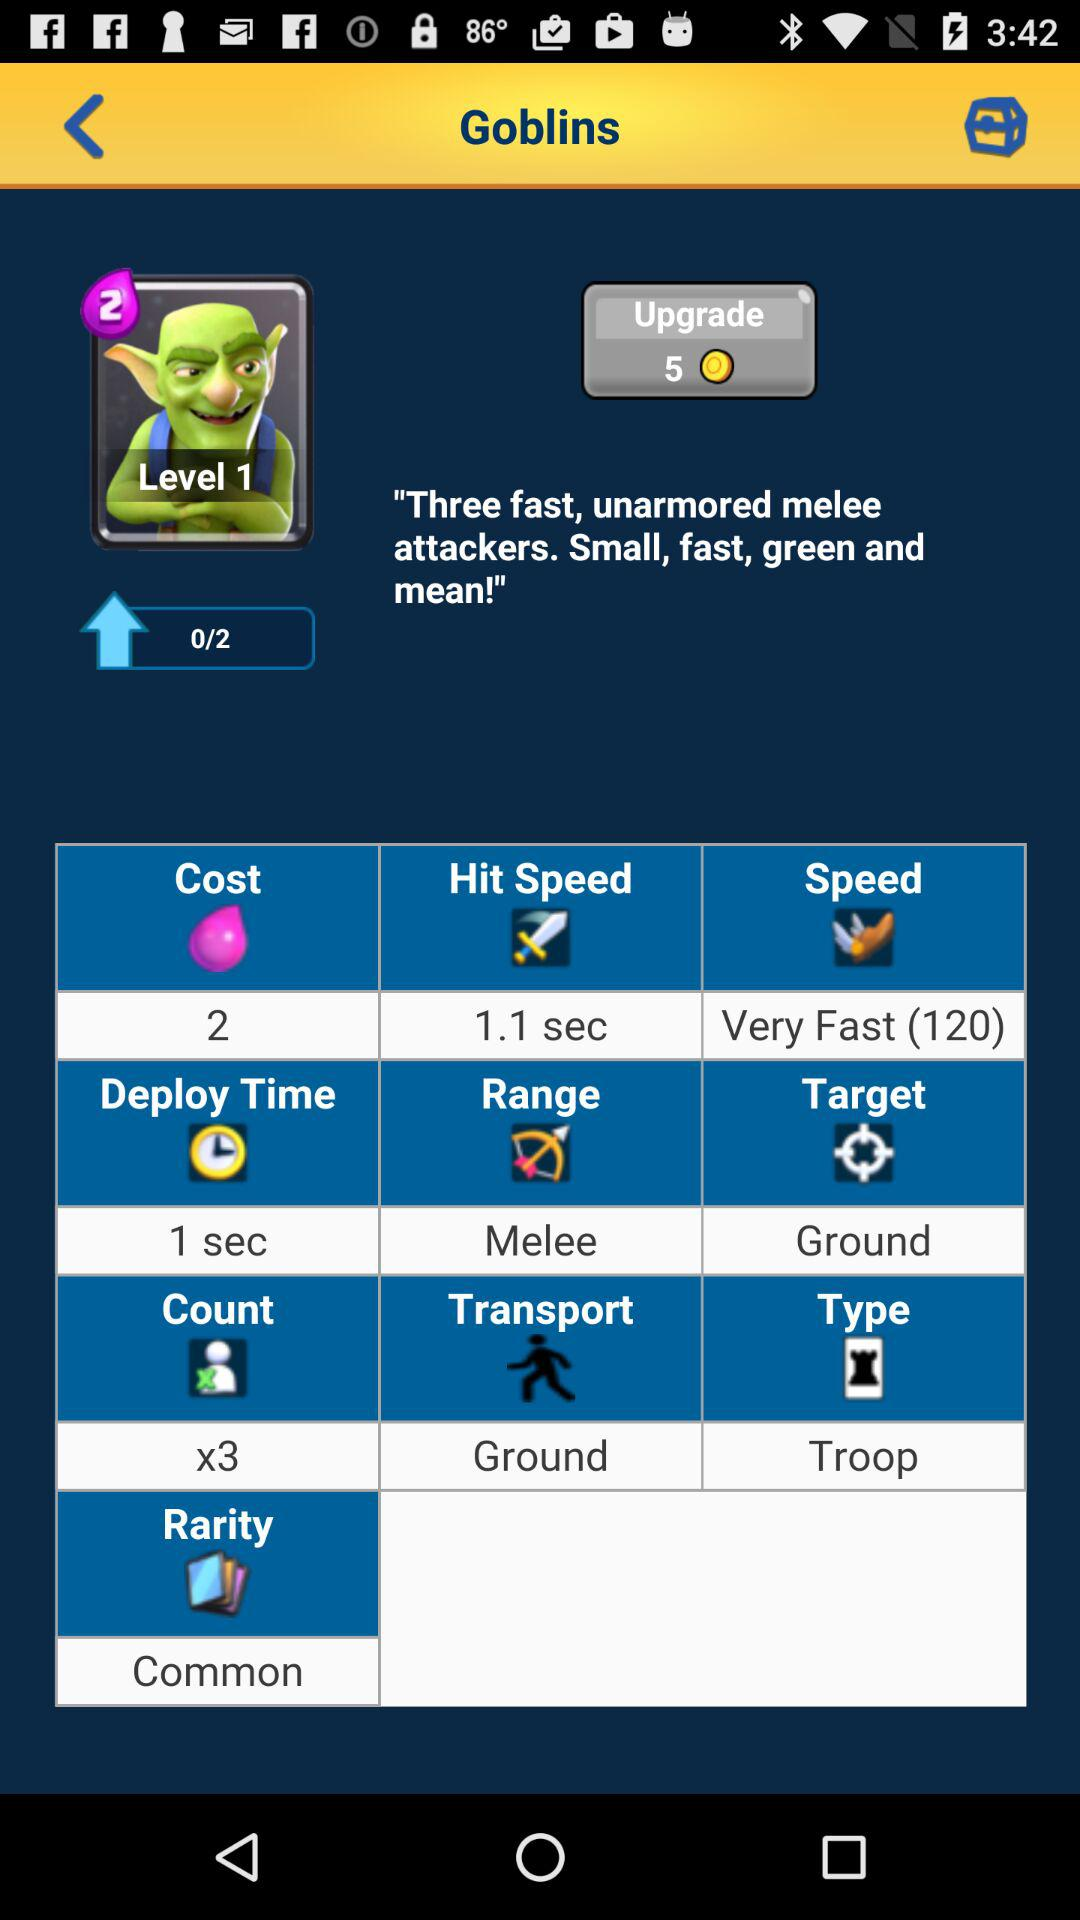What is the cost? The cost is 2. 